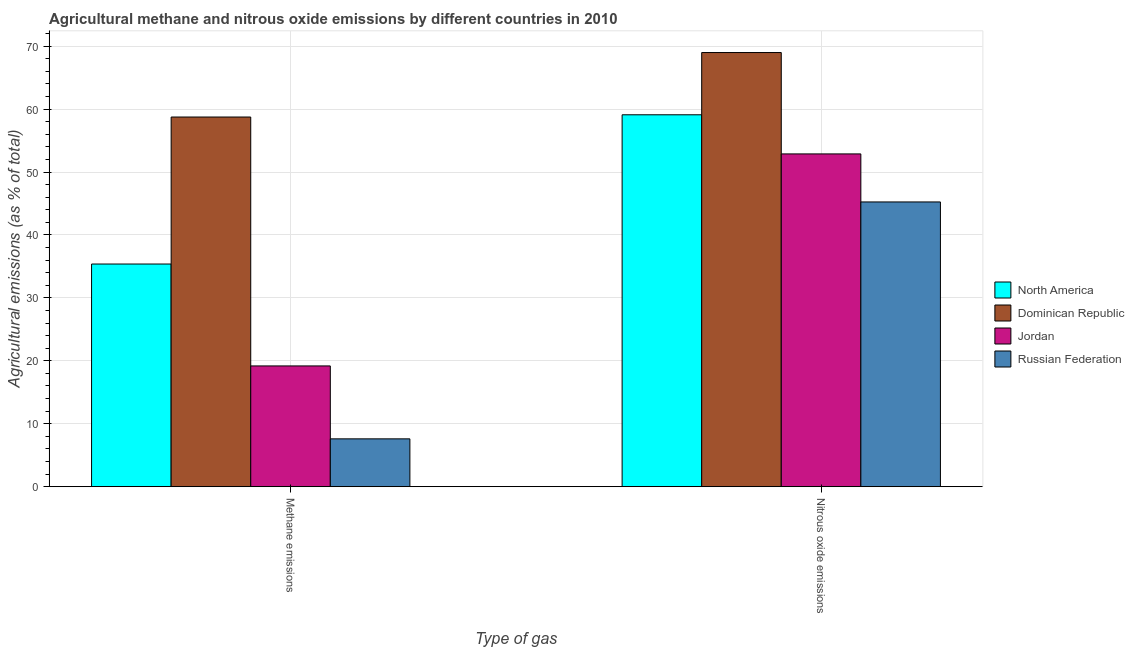How many different coloured bars are there?
Provide a short and direct response. 4. How many groups of bars are there?
Offer a terse response. 2. Are the number of bars per tick equal to the number of legend labels?
Ensure brevity in your answer.  Yes. How many bars are there on the 2nd tick from the right?
Give a very brief answer. 4. What is the label of the 1st group of bars from the left?
Your answer should be compact. Methane emissions. What is the amount of methane emissions in Jordan?
Your response must be concise. 19.19. Across all countries, what is the maximum amount of nitrous oxide emissions?
Offer a very short reply. 68.99. Across all countries, what is the minimum amount of nitrous oxide emissions?
Your response must be concise. 45.25. In which country was the amount of methane emissions maximum?
Ensure brevity in your answer.  Dominican Republic. In which country was the amount of nitrous oxide emissions minimum?
Make the answer very short. Russian Federation. What is the total amount of methane emissions in the graph?
Keep it short and to the point. 120.91. What is the difference between the amount of nitrous oxide emissions in Jordan and that in North America?
Provide a succinct answer. -6.22. What is the difference between the amount of nitrous oxide emissions in North America and the amount of methane emissions in Jordan?
Give a very brief answer. 39.91. What is the average amount of methane emissions per country?
Provide a short and direct response. 30.23. What is the difference between the amount of nitrous oxide emissions and amount of methane emissions in Russian Federation?
Your answer should be compact. 37.65. What is the ratio of the amount of methane emissions in North America to that in Jordan?
Your response must be concise. 1.84. In how many countries, is the amount of methane emissions greater than the average amount of methane emissions taken over all countries?
Keep it short and to the point. 2. What does the 2nd bar from the left in Methane emissions represents?
Provide a succinct answer. Dominican Republic. What does the 1st bar from the right in Methane emissions represents?
Provide a short and direct response. Russian Federation. How many bars are there?
Offer a very short reply. 8. What is the difference between two consecutive major ticks on the Y-axis?
Offer a very short reply. 10. Does the graph contain any zero values?
Your response must be concise. No. Where does the legend appear in the graph?
Offer a very short reply. Center right. How many legend labels are there?
Ensure brevity in your answer.  4. How are the legend labels stacked?
Your answer should be very brief. Vertical. What is the title of the graph?
Ensure brevity in your answer.  Agricultural methane and nitrous oxide emissions by different countries in 2010. What is the label or title of the X-axis?
Your answer should be compact. Type of gas. What is the label or title of the Y-axis?
Provide a short and direct response. Agricultural emissions (as % of total). What is the Agricultural emissions (as % of total) in North America in Methane emissions?
Your response must be concise. 35.38. What is the Agricultural emissions (as % of total) of Dominican Republic in Methane emissions?
Provide a succinct answer. 58.74. What is the Agricultural emissions (as % of total) of Jordan in Methane emissions?
Your answer should be compact. 19.19. What is the Agricultural emissions (as % of total) in Russian Federation in Methane emissions?
Your answer should be very brief. 7.6. What is the Agricultural emissions (as % of total) of North America in Nitrous oxide emissions?
Make the answer very short. 59.09. What is the Agricultural emissions (as % of total) of Dominican Republic in Nitrous oxide emissions?
Make the answer very short. 68.99. What is the Agricultural emissions (as % of total) of Jordan in Nitrous oxide emissions?
Offer a terse response. 52.88. What is the Agricultural emissions (as % of total) in Russian Federation in Nitrous oxide emissions?
Your answer should be compact. 45.25. Across all Type of gas, what is the maximum Agricultural emissions (as % of total) of North America?
Give a very brief answer. 59.09. Across all Type of gas, what is the maximum Agricultural emissions (as % of total) in Dominican Republic?
Offer a very short reply. 68.99. Across all Type of gas, what is the maximum Agricultural emissions (as % of total) of Jordan?
Provide a short and direct response. 52.88. Across all Type of gas, what is the maximum Agricultural emissions (as % of total) in Russian Federation?
Make the answer very short. 45.25. Across all Type of gas, what is the minimum Agricultural emissions (as % of total) in North America?
Ensure brevity in your answer.  35.38. Across all Type of gas, what is the minimum Agricultural emissions (as % of total) in Dominican Republic?
Your response must be concise. 58.74. Across all Type of gas, what is the minimum Agricultural emissions (as % of total) in Jordan?
Make the answer very short. 19.19. Across all Type of gas, what is the minimum Agricultural emissions (as % of total) of Russian Federation?
Keep it short and to the point. 7.6. What is the total Agricultural emissions (as % of total) in North America in the graph?
Your answer should be compact. 94.48. What is the total Agricultural emissions (as % of total) in Dominican Republic in the graph?
Ensure brevity in your answer.  127.73. What is the total Agricultural emissions (as % of total) of Jordan in the graph?
Keep it short and to the point. 72.06. What is the total Agricultural emissions (as % of total) in Russian Federation in the graph?
Offer a terse response. 52.85. What is the difference between the Agricultural emissions (as % of total) in North America in Methane emissions and that in Nitrous oxide emissions?
Offer a very short reply. -23.71. What is the difference between the Agricultural emissions (as % of total) of Dominican Republic in Methane emissions and that in Nitrous oxide emissions?
Make the answer very short. -10.25. What is the difference between the Agricultural emissions (as % of total) in Jordan in Methane emissions and that in Nitrous oxide emissions?
Make the answer very short. -33.69. What is the difference between the Agricultural emissions (as % of total) in Russian Federation in Methane emissions and that in Nitrous oxide emissions?
Provide a succinct answer. -37.65. What is the difference between the Agricultural emissions (as % of total) in North America in Methane emissions and the Agricultural emissions (as % of total) in Dominican Republic in Nitrous oxide emissions?
Your answer should be very brief. -33.61. What is the difference between the Agricultural emissions (as % of total) in North America in Methane emissions and the Agricultural emissions (as % of total) in Jordan in Nitrous oxide emissions?
Offer a terse response. -17.49. What is the difference between the Agricultural emissions (as % of total) in North America in Methane emissions and the Agricultural emissions (as % of total) in Russian Federation in Nitrous oxide emissions?
Your answer should be very brief. -9.86. What is the difference between the Agricultural emissions (as % of total) in Dominican Republic in Methane emissions and the Agricultural emissions (as % of total) in Jordan in Nitrous oxide emissions?
Ensure brevity in your answer.  5.86. What is the difference between the Agricultural emissions (as % of total) of Dominican Republic in Methane emissions and the Agricultural emissions (as % of total) of Russian Federation in Nitrous oxide emissions?
Make the answer very short. 13.49. What is the difference between the Agricultural emissions (as % of total) of Jordan in Methane emissions and the Agricultural emissions (as % of total) of Russian Federation in Nitrous oxide emissions?
Provide a succinct answer. -26.06. What is the average Agricultural emissions (as % of total) in North America per Type of gas?
Offer a terse response. 47.24. What is the average Agricultural emissions (as % of total) of Dominican Republic per Type of gas?
Give a very brief answer. 63.86. What is the average Agricultural emissions (as % of total) of Jordan per Type of gas?
Provide a short and direct response. 36.03. What is the average Agricultural emissions (as % of total) in Russian Federation per Type of gas?
Give a very brief answer. 26.42. What is the difference between the Agricultural emissions (as % of total) in North America and Agricultural emissions (as % of total) in Dominican Republic in Methane emissions?
Offer a very short reply. -23.36. What is the difference between the Agricultural emissions (as % of total) in North America and Agricultural emissions (as % of total) in Jordan in Methane emissions?
Provide a succinct answer. 16.19. What is the difference between the Agricultural emissions (as % of total) of North America and Agricultural emissions (as % of total) of Russian Federation in Methane emissions?
Make the answer very short. 27.78. What is the difference between the Agricultural emissions (as % of total) in Dominican Republic and Agricultural emissions (as % of total) in Jordan in Methane emissions?
Ensure brevity in your answer.  39.55. What is the difference between the Agricultural emissions (as % of total) of Dominican Republic and Agricultural emissions (as % of total) of Russian Federation in Methane emissions?
Offer a terse response. 51.14. What is the difference between the Agricultural emissions (as % of total) of Jordan and Agricultural emissions (as % of total) of Russian Federation in Methane emissions?
Your answer should be compact. 11.59. What is the difference between the Agricultural emissions (as % of total) of North America and Agricultural emissions (as % of total) of Dominican Republic in Nitrous oxide emissions?
Make the answer very short. -9.89. What is the difference between the Agricultural emissions (as % of total) in North America and Agricultural emissions (as % of total) in Jordan in Nitrous oxide emissions?
Keep it short and to the point. 6.22. What is the difference between the Agricultural emissions (as % of total) in North America and Agricultural emissions (as % of total) in Russian Federation in Nitrous oxide emissions?
Keep it short and to the point. 13.85. What is the difference between the Agricultural emissions (as % of total) in Dominican Republic and Agricultural emissions (as % of total) in Jordan in Nitrous oxide emissions?
Offer a very short reply. 16.11. What is the difference between the Agricultural emissions (as % of total) in Dominican Republic and Agricultural emissions (as % of total) in Russian Federation in Nitrous oxide emissions?
Make the answer very short. 23.74. What is the difference between the Agricultural emissions (as % of total) in Jordan and Agricultural emissions (as % of total) in Russian Federation in Nitrous oxide emissions?
Your response must be concise. 7.63. What is the ratio of the Agricultural emissions (as % of total) in North America in Methane emissions to that in Nitrous oxide emissions?
Give a very brief answer. 0.6. What is the ratio of the Agricultural emissions (as % of total) in Dominican Republic in Methane emissions to that in Nitrous oxide emissions?
Provide a short and direct response. 0.85. What is the ratio of the Agricultural emissions (as % of total) in Jordan in Methane emissions to that in Nitrous oxide emissions?
Offer a very short reply. 0.36. What is the ratio of the Agricultural emissions (as % of total) of Russian Federation in Methane emissions to that in Nitrous oxide emissions?
Your answer should be very brief. 0.17. What is the difference between the highest and the second highest Agricultural emissions (as % of total) in North America?
Provide a succinct answer. 23.71. What is the difference between the highest and the second highest Agricultural emissions (as % of total) of Dominican Republic?
Give a very brief answer. 10.25. What is the difference between the highest and the second highest Agricultural emissions (as % of total) of Jordan?
Your response must be concise. 33.69. What is the difference between the highest and the second highest Agricultural emissions (as % of total) in Russian Federation?
Provide a succinct answer. 37.65. What is the difference between the highest and the lowest Agricultural emissions (as % of total) in North America?
Your response must be concise. 23.71. What is the difference between the highest and the lowest Agricultural emissions (as % of total) in Dominican Republic?
Give a very brief answer. 10.25. What is the difference between the highest and the lowest Agricultural emissions (as % of total) of Jordan?
Provide a succinct answer. 33.69. What is the difference between the highest and the lowest Agricultural emissions (as % of total) in Russian Federation?
Keep it short and to the point. 37.65. 